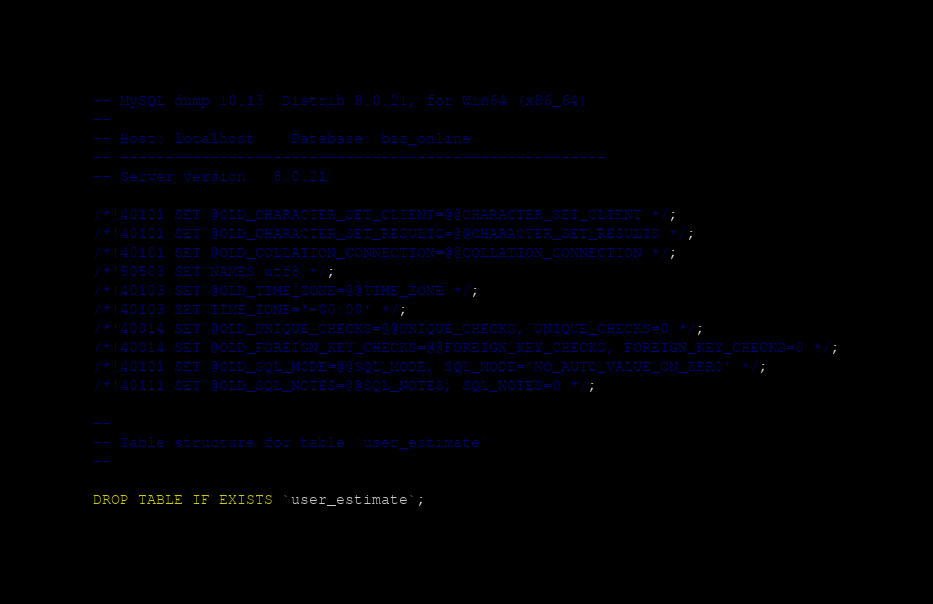Convert code to text. <code><loc_0><loc_0><loc_500><loc_500><_SQL_>-- MySQL dump 10.13  Distrib 8.0.21, for Win64 (x86_64)
--
-- Host: localhost    Database: biz_online
-- ------------------------------------------------------
-- Server version	8.0.21

/*!40101 SET @OLD_CHARACTER_SET_CLIENT=@@CHARACTER_SET_CLIENT */;
/*!40101 SET @OLD_CHARACTER_SET_RESULTS=@@CHARACTER_SET_RESULTS */;
/*!40101 SET @OLD_COLLATION_CONNECTION=@@COLLATION_CONNECTION */;
/*!50503 SET NAMES utf8 */;
/*!40103 SET @OLD_TIME_ZONE=@@TIME_ZONE */;
/*!40103 SET TIME_ZONE='+00:00' */;
/*!40014 SET @OLD_UNIQUE_CHECKS=@@UNIQUE_CHECKS, UNIQUE_CHECKS=0 */;
/*!40014 SET @OLD_FOREIGN_KEY_CHECKS=@@FOREIGN_KEY_CHECKS, FOREIGN_KEY_CHECKS=0 */;
/*!40101 SET @OLD_SQL_MODE=@@SQL_MODE, SQL_MODE='NO_AUTO_VALUE_ON_ZERO' */;
/*!40111 SET @OLD_SQL_NOTES=@@SQL_NOTES, SQL_NOTES=0 */;

--
-- Table structure for table `user_estimate`
--

DROP TABLE IF EXISTS `user_estimate`;</code> 